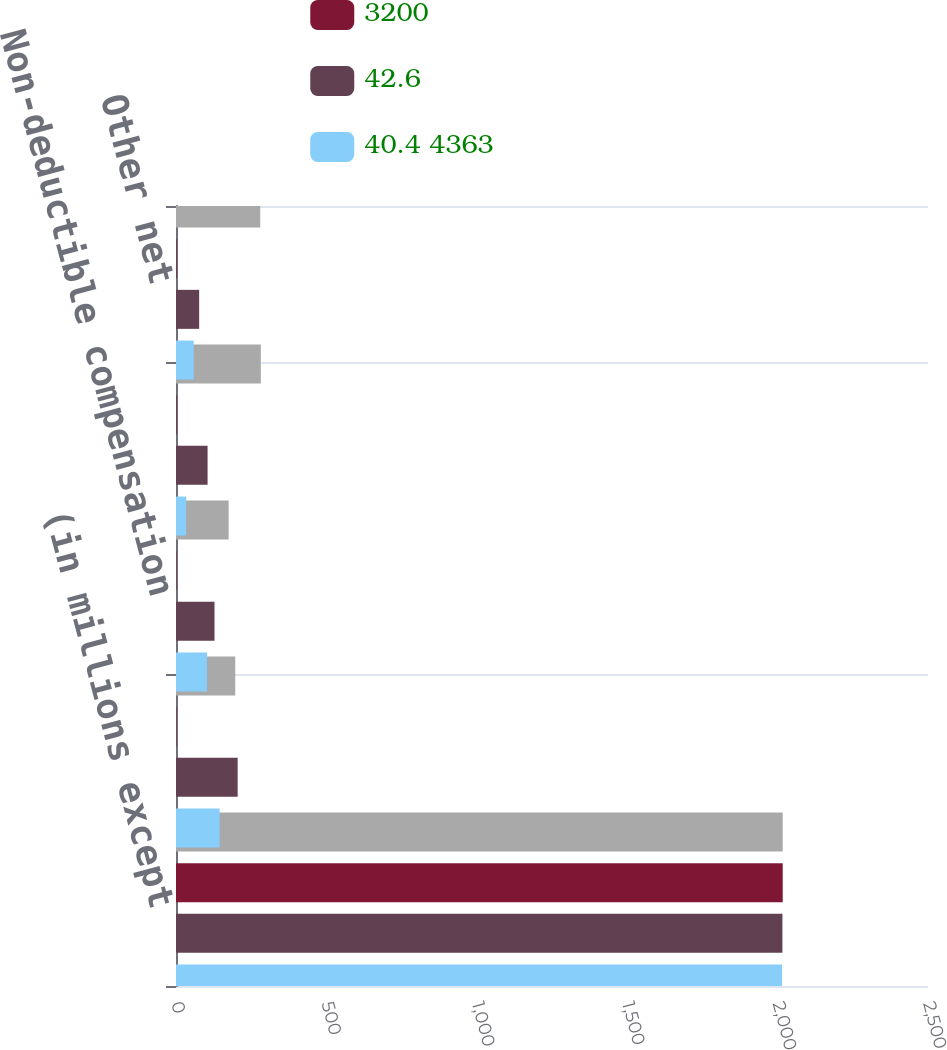<chart> <loc_0><loc_0><loc_500><loc_500><stacked_bar_chart><ecel><fcel>(in millions except<fcel>State income taxes net of<fcel>Non-deductible compensation<fcel>Foreign rate differential<fcel>Other net<nl><fcel>nan<fcel>2017<fcel>197<fcel>175<fcel>282<fcel>280<nl><fcel>3200<fcel>2017<fcel>1.4<fcel>1.3<fcel>2<fcel>2<nl><fcel>42.6<fcel>2016<fcel>205<fcel>128<fcel>105<fcel>77<nl><fcel>40.4 4363<fcel>2015<fcel>145<fcel>103<fcel>34<fcel>59<nl></chart> 